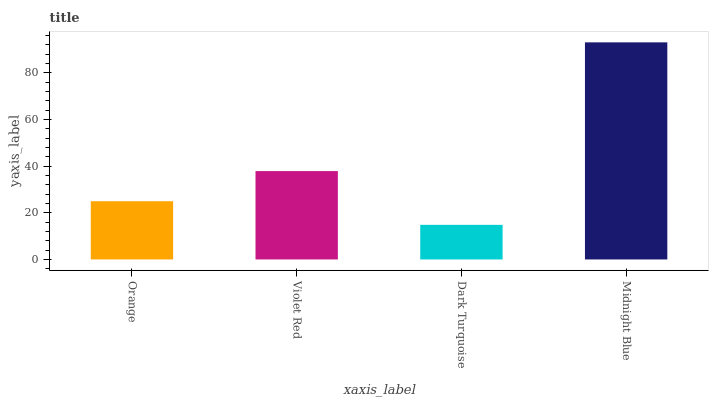Is Dark Turquoise the minimum?
Answer yes or no. Yes. Is Midnight Blue the maximum?
Answer yes or no. Yes. Is Violet Red the minimum?
Answer yes or no. No. Is Violet Red the maximum?
Answer yes or no. No. Is Violet Red greater than Orange?
Answer yes or no. Yes. Is Orange less than Violet Red?
Answer yes or no. Yes. Is Orange greater than Violet Red?
Answer yes or no. No. Is Violet Red less than Orange?
Answer yes or no. No. Is Violet Red the high median?
Answer yes or no. Yes. Is Orange the low median?
Answer yes or no. Yes. Is Dark Turquoise the high median?
Answer yes or no. No. Is Dark Turquoise the low median?
Answer yes or no. No. 